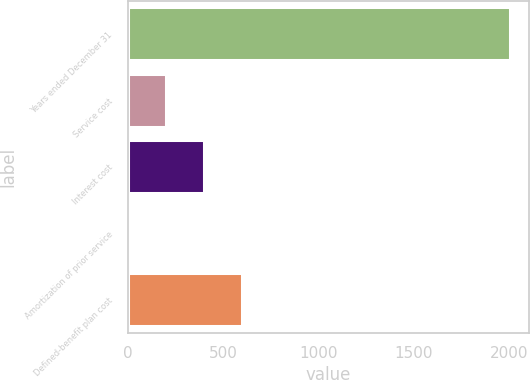Convert chart. <chart><loc_0><loc_0><loc_500><loc_500><bar_chart><fcel>Years ended December 31<fcel>Service cost<fcel>Interest cost<fcel>Amortization of prior service<fcel>Defined-benefit plan cost<nl><fcel>2004<fcel>200.49<fcel>400.88<fcel>0.1<fcel>601.27<nl></chart> 